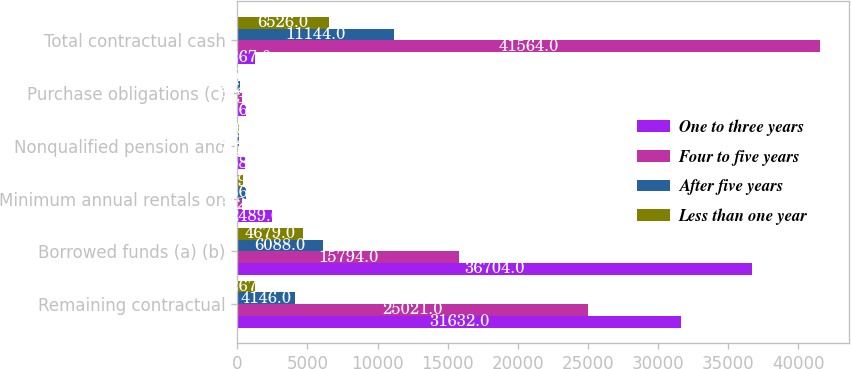Convert chart to OTSL. <chart><loc_0><loc_0><loc_500><loc_500><stacked_bar_chart><ecel><fcel>Remaining contractual<fcel>Borrowed funds (a) (b)<fcel>Minimum annual rentals on<fcel>Nonqualified pension and<fcel>Purchase obligations (c)<fcel>Total contractual cash<nl><fcel>One to three years<fcel>31632<fcel>36704<fcel>2489<fcel>558<fcel>616<fcel>1267<nl><fcel>Four to five years<fcel>25021<fcel>15794<fcel>342<fcel>64<fcel>343<fcel>41564<nl><fcel>After five years<fcel>4146<fcel>6088<fcel>586<fcel>122<fcel>202<fcel>11144<nl><fcel>Less than one year<fcel>1267<fcel>4679<fcel>409<fcel>116<fcel>55<fcel>6526<nl></chart> 